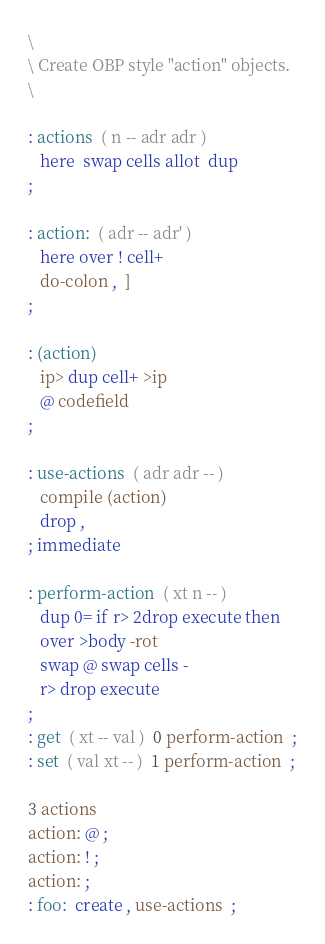<code> <loc_0><loc_0><loc_500><loc_500><_Forth_>\
\ Create OBP style "action" objects.
\

: actions  ( n -- adr adr )
   here  swap cells allot  dup
;

: action:  ( adr -- adr' )
   here over ! cell+
   do-colon ,  ]
;

: (action)
   ip> dup cell+ >ip
   @ codefield
;

: use-actions  ( adr adr -- )
   compile (action)
   drop ,
; immediate

: perform-action  ( xt n -- )
   dup 0= if r> 2drop execute then
   over >body -rot
   swap @ swap cells -
   r> drop execute
;
: get  ( xt -- val )  0 perform-action  ;
: set  ( val xt -- )  1 perform-action  ;

3 actions
action: @ ;
action: ! ;
action: ;
: foo:  create , use-actions  ;

</code> 